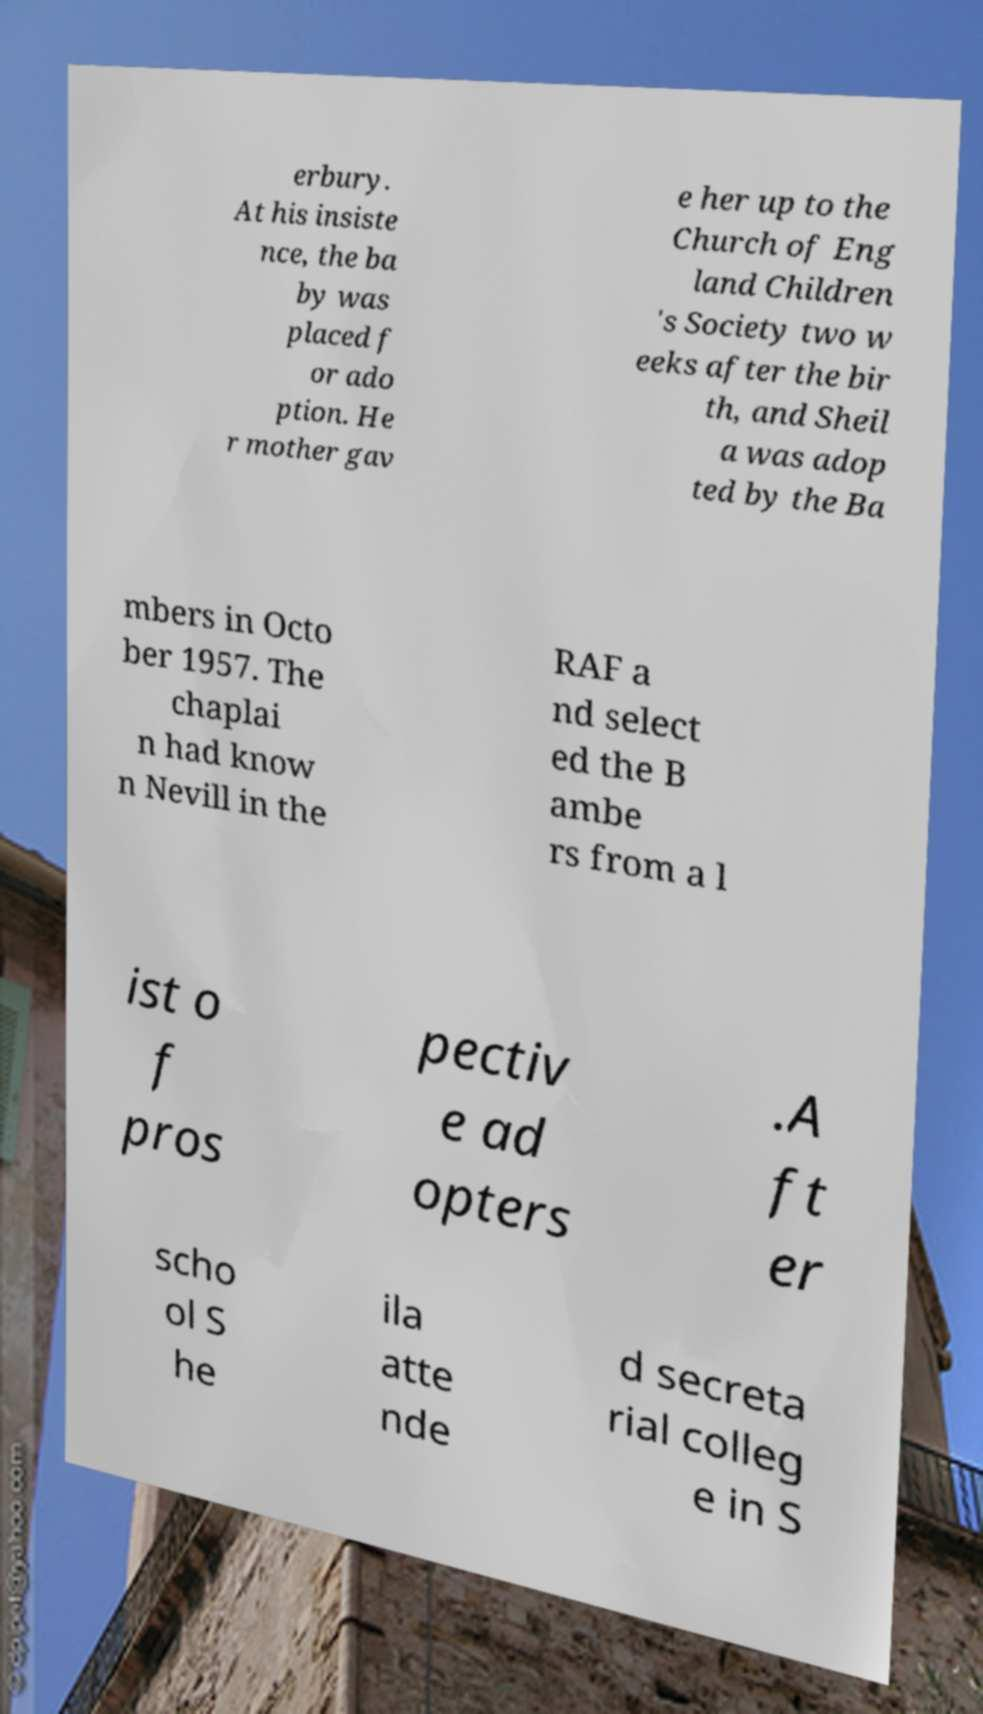For documentation purposes, I need the text within this image transcribed. Could you provide that? erbury. At his insiste nce, the ba by was placed f or ado ption. He r mother gav e her up to the Church of Eng land Children 's Society two w eeks after the bir th, and Sheil a was adop ted by the Ba mbers in Octo ber 1957. The chaplai n had know n Nevill in the RAF a nd select ed the B ambe rs from a l ist o f pros pectiv e ad opters .A ft er scho ol S he ila atte nde d secreta rial colleg e in S 